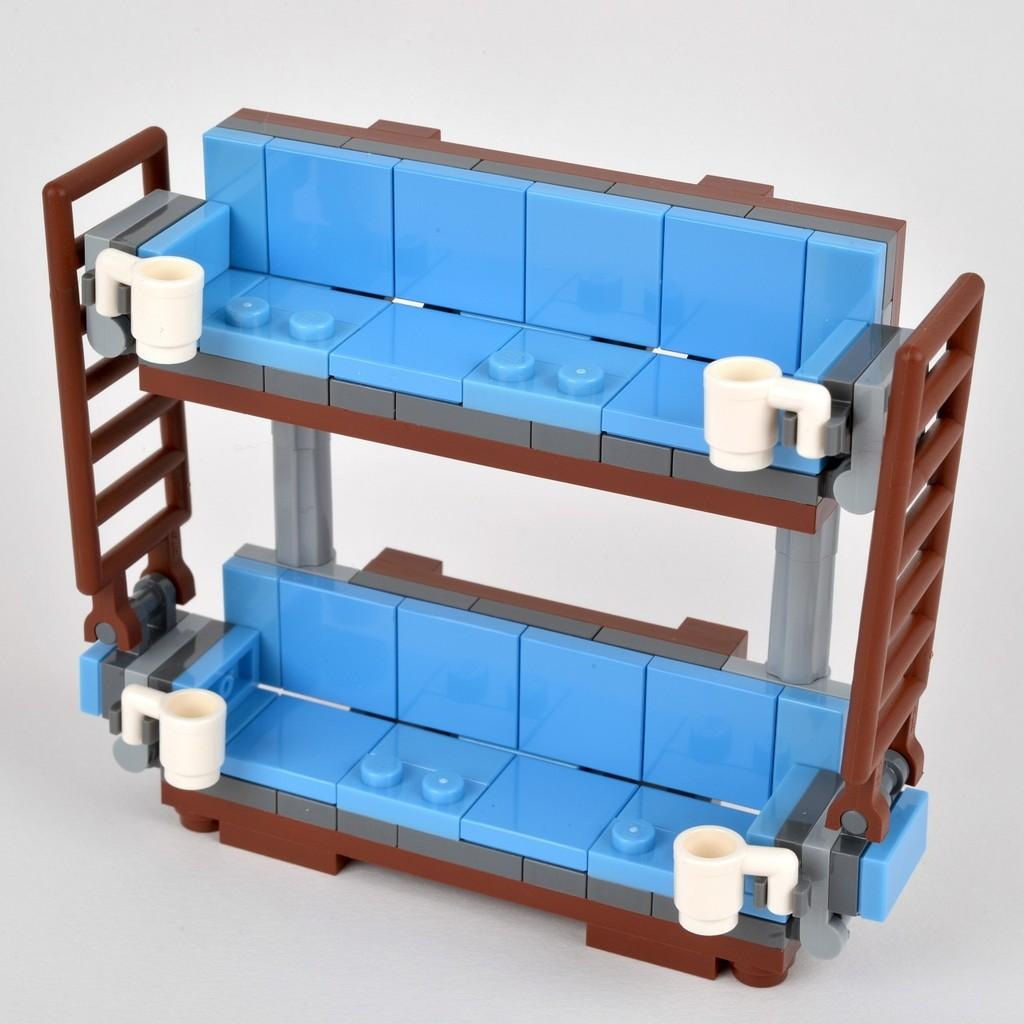What is the main subject in the center of the image? There is a Lego in the center of the image. What structure can be seen in the image? There is a rack in the image. What color are some of the objects in the image? There are white color objects in the image. Are there any other objects present in the image besides the Lego and the rack? Yes, there are other objects in the image. Can you see a dog playing with a bait in the image? No, there is no dog or bait present in the image. What type of soda is being served in the image? There is no soda or any food or drink items present in the image. 